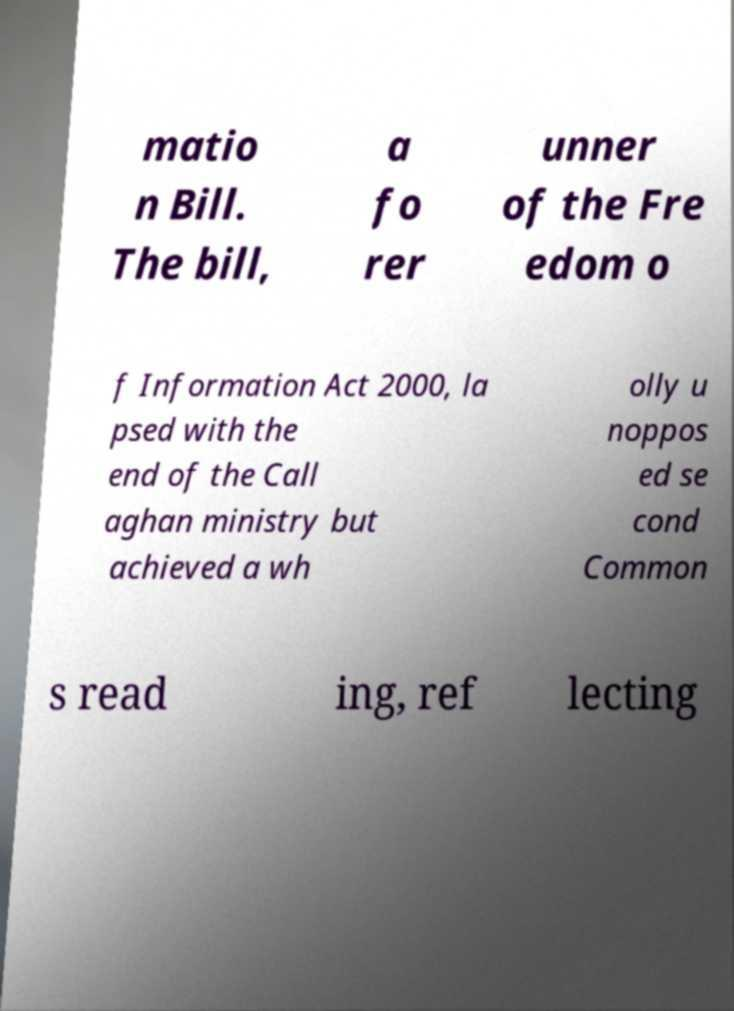There's text embedded in this image that I need extracted. Can you transcribe it verbatim? matio n Bill. The bill, a fo rer unner of the Fre edom o f Information Act 2000, la psed with the end of the Call aghan ministry but achieved a wh olly u noppos ed se cond Common s read ing, ref lecting 